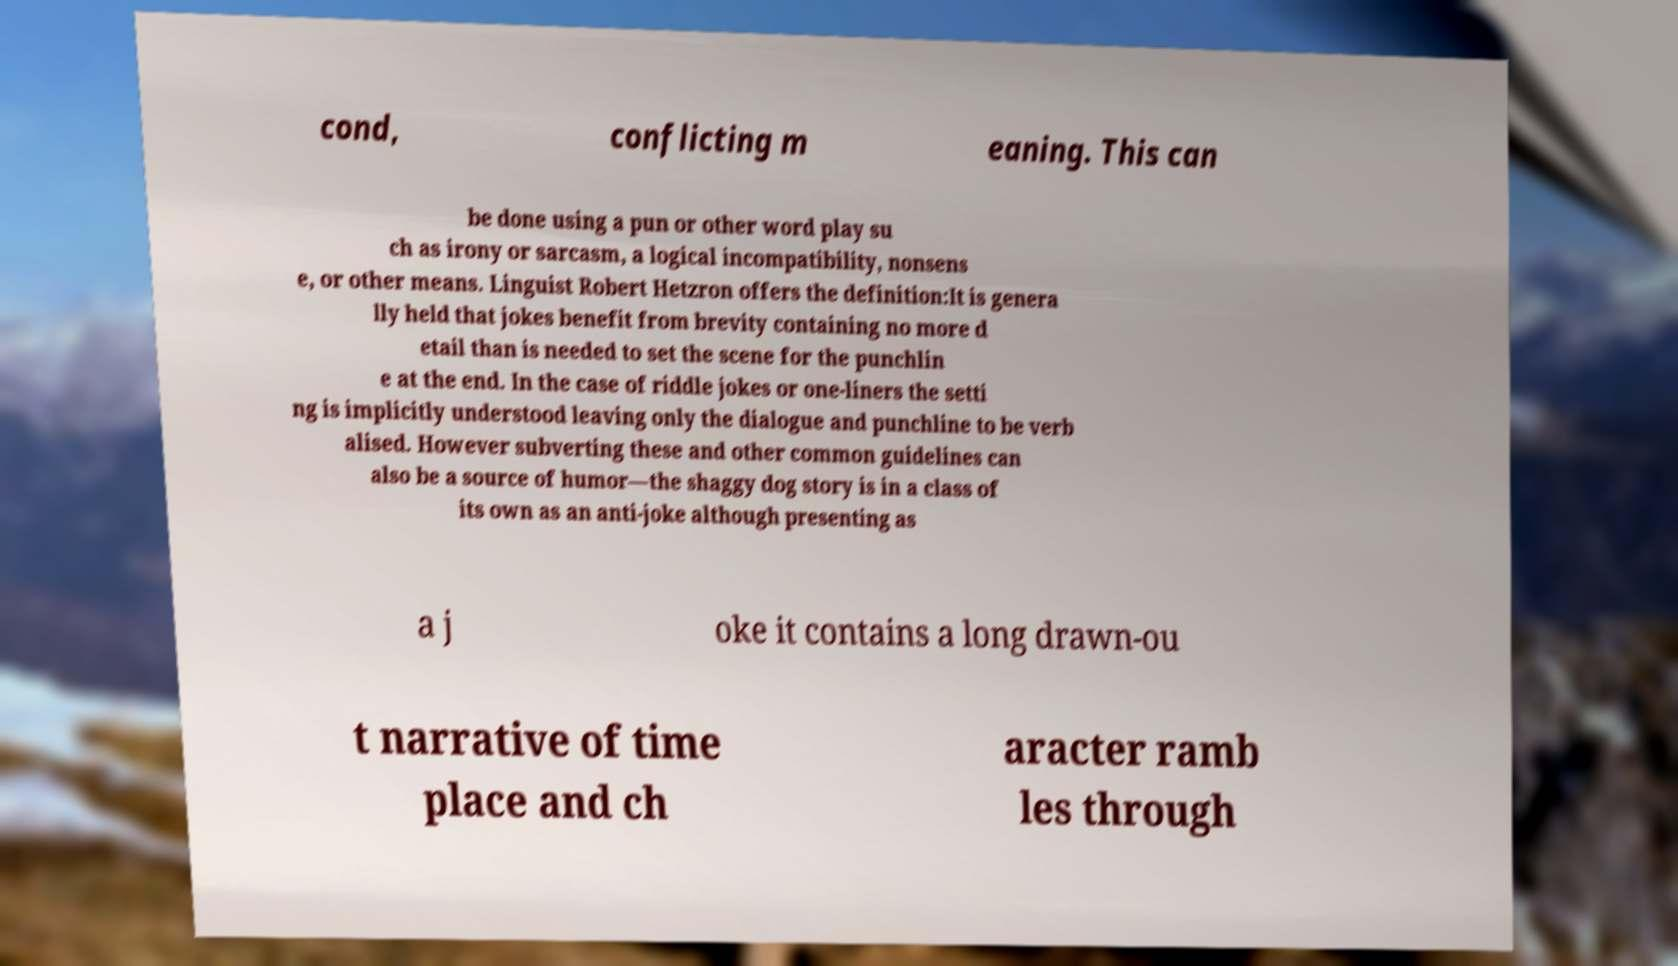Could you extract and type out the text from this image? cond, conflicting m eaning. This can be done using a pun or other word play su ch as irony or sarcasm, a logical incompatibility, nonsens e, or other means. Linguist Robert Hetzron offers the definition:It is genera lly held that jokes benefit from brevity containing no more d etail than is needed to set the scene for the punchlin e at the end. In the case of riddle jokes or one-liners the setti ng is implicitly understood leaving only the dialogue and punchline to be verb alised. However subverting these and other common guidelines can also be a source of humor—the shaggy dog story is in a class of its own as an anti-joke although presenting as a j oke it contains a long drawn-ou t narrative of time place and ch aracter ramb les through 